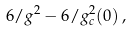<formula> <loc_0><loc_0><loc_500><loc_500>6 / g ^ { 2 } - 6 / g _ { c } ^ { 2 } ( 0 ) \, ,</formula> 